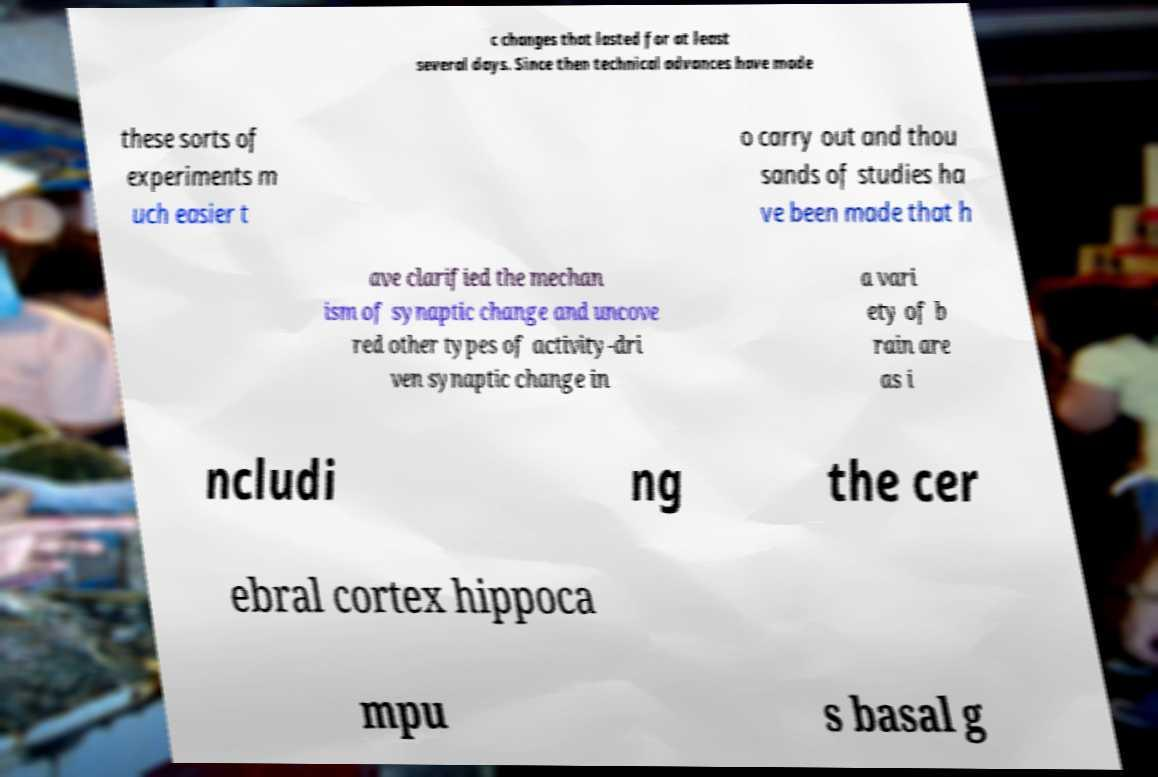For documentation purposes, I need the text within this image transcribed. Could you provide that? c changes that lasted for at least several days. Since then technical advances have made these sorts of experiments m uch easier t o carry out and thou sands of studies ha ve been made that h ave clarified the mechan ism of synaptic change and uncove red other types of activity-dri ven synaptic change in a vari ety of b rain are as i ncludi ng the cer ebral cortex hippoca mpu s basal g 